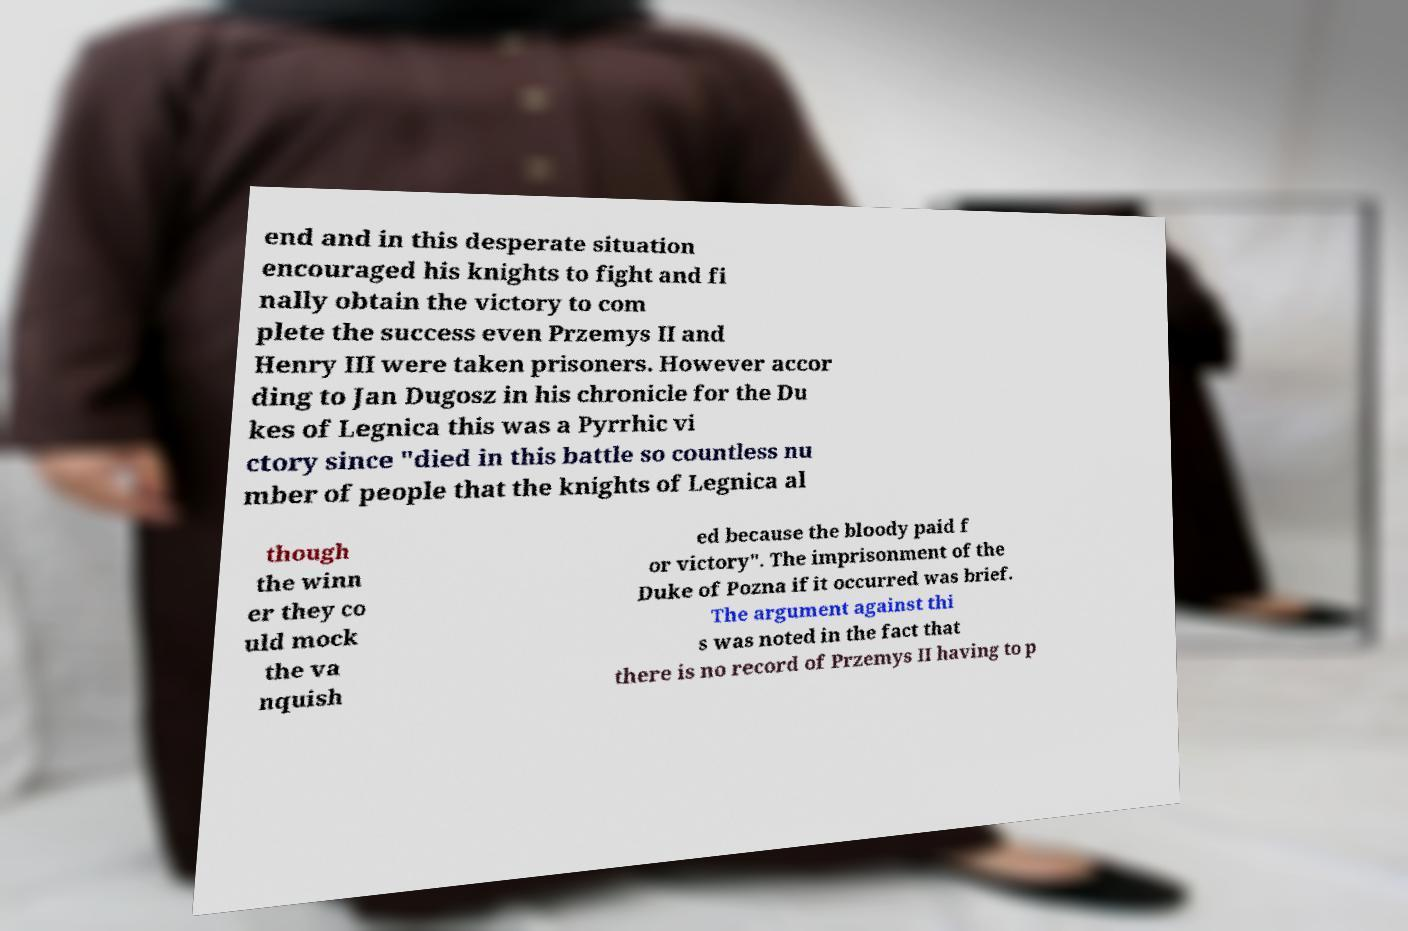Can you accurately transcribe the text from the provided image for me? end and in this desperate situation encouraged his knights to fight and fi nally obtain the victory to com plete the success even Przemys II and Henry III were taken prisoners. However accor ding to Jan Dugosz in his chronicle for the Du kes of Legnica this was a Pyrrhic vi ctory since "died in this battle so countless nu mber of people that the knights of Legnica al though the winn er they co uld mock the va nquish ed because the bloody paid f or victory". The imprisonment of the Duke of Pozna if it occurred was brief. The argument against thi s was noted in the fact that there is no record of Przemys II having to p 